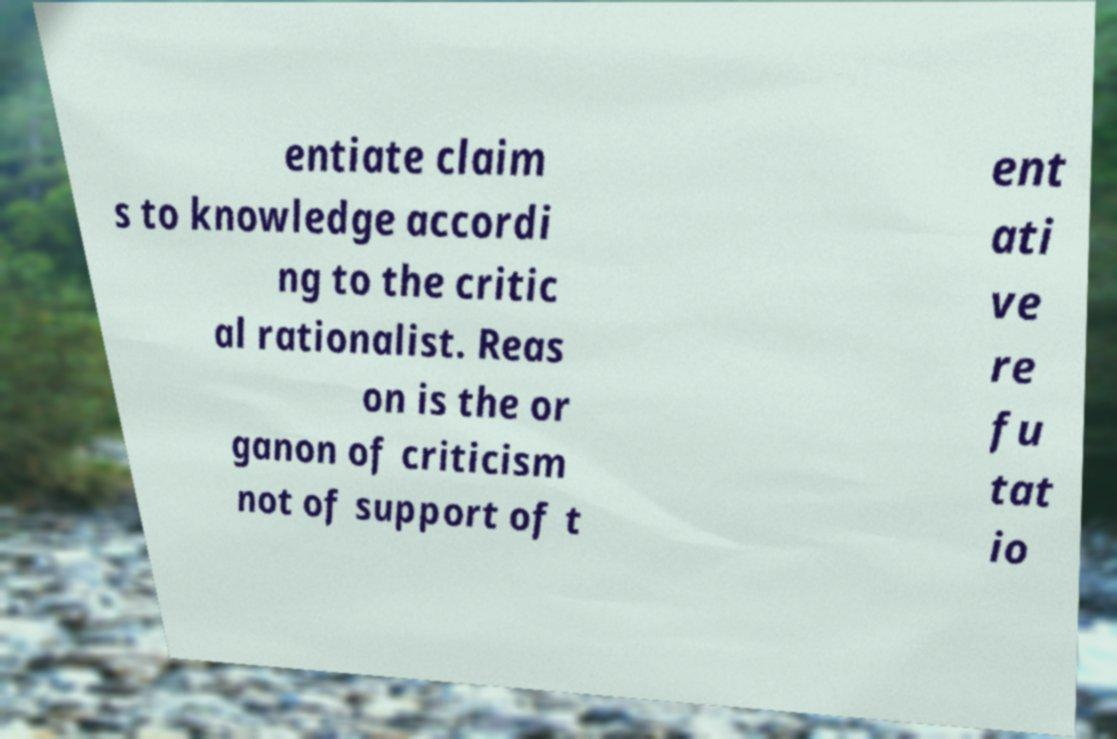I need the written content from this picture converted into text. Can you do that? entiate claim s to knowledge accordi ng to the critic al rationalist. Reas on is the or ganon of criticism not of support of t ent ati ve re fu tat io 